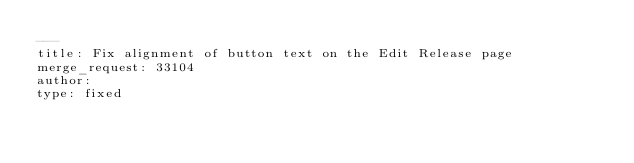Convert code to text. <code><loc_0><loc_0><loc_500><loc_500><_YAML_>---
title: Fix alignment of button text on the Edit Release page
merge_request: 33104
author:
type: fixed
</code> 